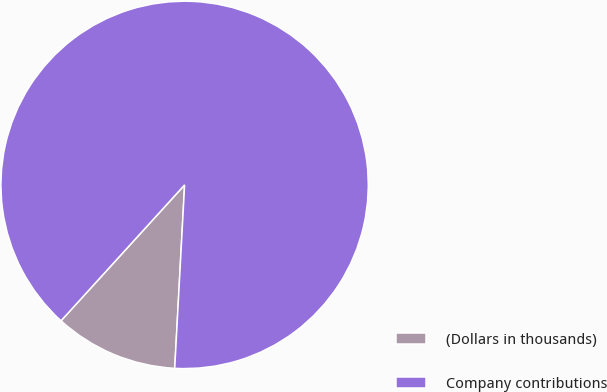Convert chart to OTSL. <chart><loc_0><loc_0><loc_500><loc_500><pie_chart><fcel>(Dollars in thousands)<fcel>Company contributions<nl><fcel>10.89%<fcel>89.11%<nl></chart> 